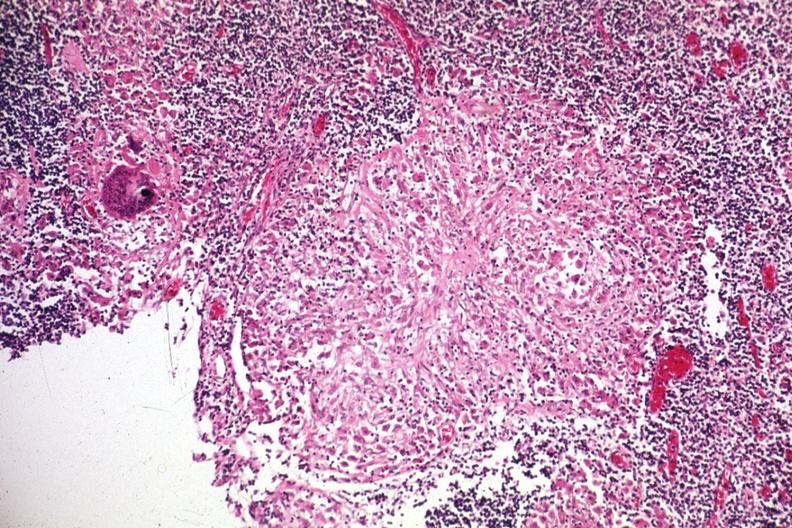s lymph node present?
Answer the question using a single word or phrase. Yes 